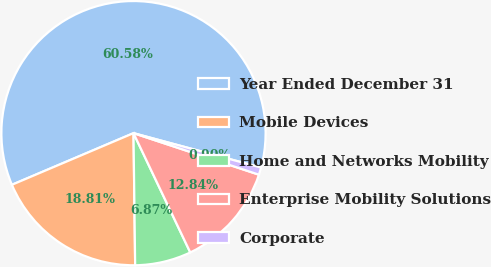Convert chart to OTSL. <chart><loc_0><loc_0><loc_500><loc_500><pie_chart><fcel>Year Ended December 31<fcel>Mobile Devices<fcel>Home and Networks Mobility<fcel>Enterprise Mobility Solutions<fcel>Corporate<nl><fcel>60.58%<fcel>18.81%<fcel>6.87%<fcel>12.84%<fcel>0.9%<nl></chart> 